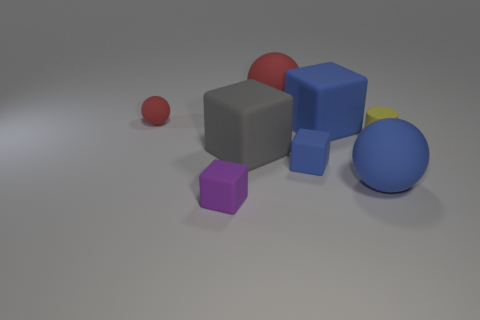Add 1 tiny purple rubber cylinders. How many objects exist? 9 Subtract all cylinders. How many objects are left? 7 Add 6 blue things. How many blue things are left? 9 Add 4 blue rubber objects. How many blue rubber objects exist? 7 Subtract 0 green blocks. How many objects are left? 8 Subtract all tiny cubes. Subtract all tiny matte cubes. How many objects are left? 4 